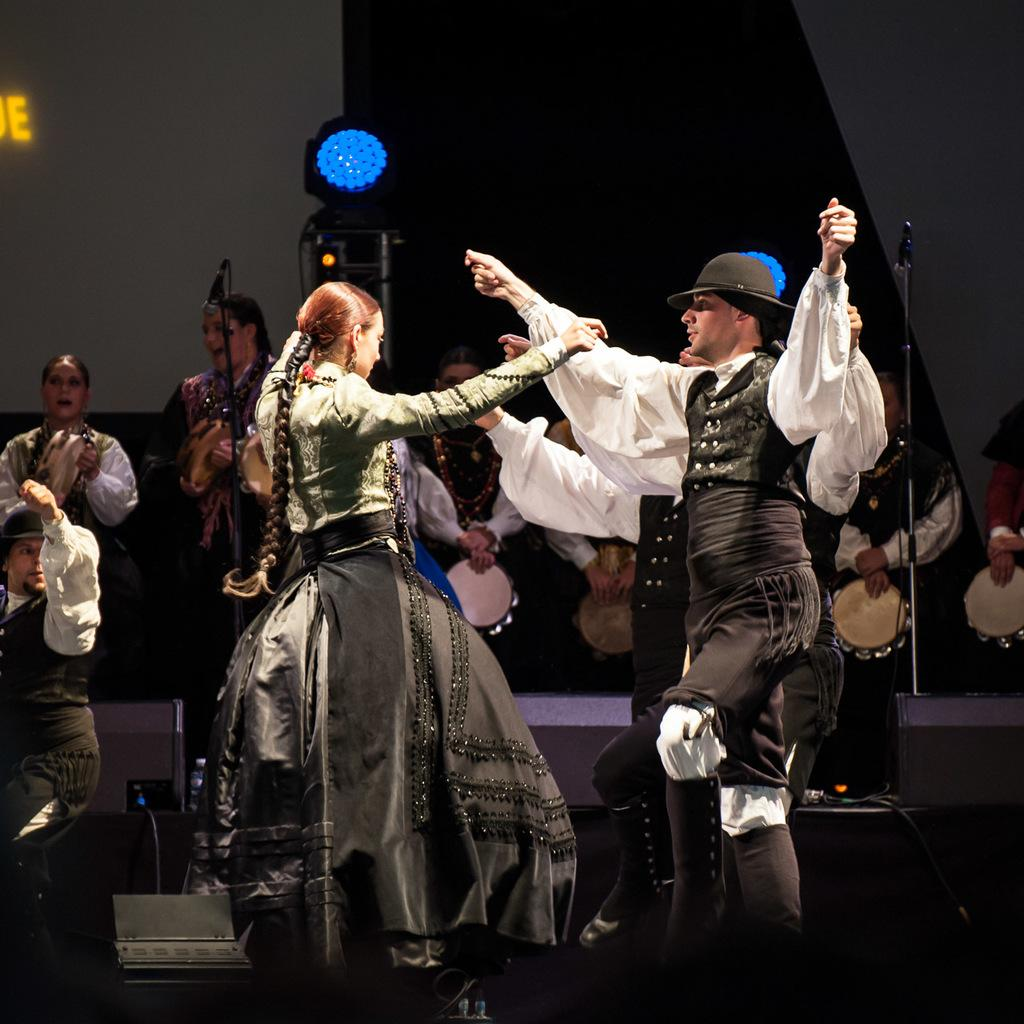What are the people in the image doing? The people in the image are dancing and playing musical instruments. Can you describe the activities of the people in the image? Some people are dancing, while others are playing musical instruments. What type of shade is being used to help with digestion during the performance in the image? There is no mention of shade or digestion in the image; it simply shows people dancing and playing musical instruments. 